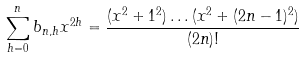Convert formula to latex. <formula><loc_0><loc_0><loc_500><loc_500>\sum _ { h = 0 } ^ { n } b _ { n , h } x ^ { 2 h } = \frac { ( x ^ { 2 } + 1 ^ { 2 } ) \dots ( x ^ { 2 } + ( 2 n - 1 ) ^ { 2 } ) } { ( 2 n ) ! }</formula> 